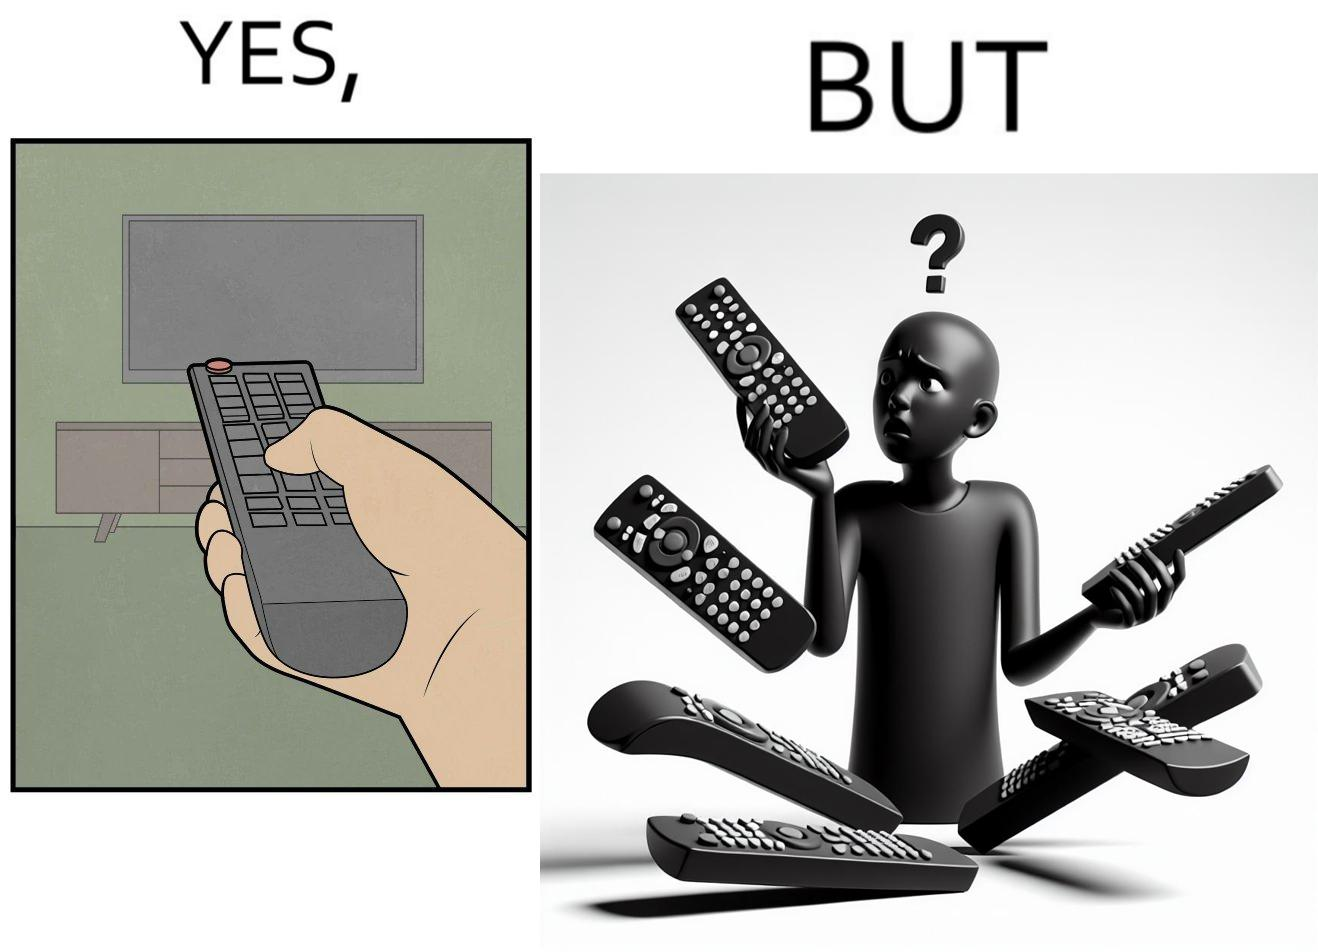Is there satirical content in this image? Yes, this image is satirical. 